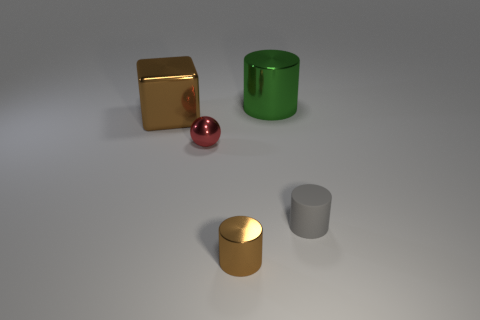Add 4 matte objects. How many objects exist? 9 Subtract all cylinders. How many objects are left? 2 Subtract all tiny brown cylinders. Subtract all cylinders. How many objects are left? 1 Add 3 brown blocks. How many brown blocks are left? 4 Add 4 brown rubber cylinders. How many brown rubber cylinders exist? 4 Subtract 0 purple spheres. How many objects are left? 5 